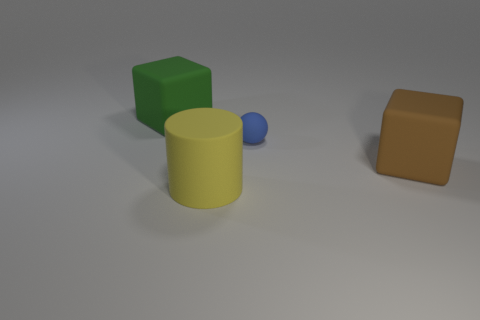How many objects are there in total, regardless of size or color? In the image, there are a total of four objects. Can you describe the shapes of the items shown? Of course! There's a blue spherical ball, a yellow cylindrical object, a green cube, and a brown rectangular prism. 